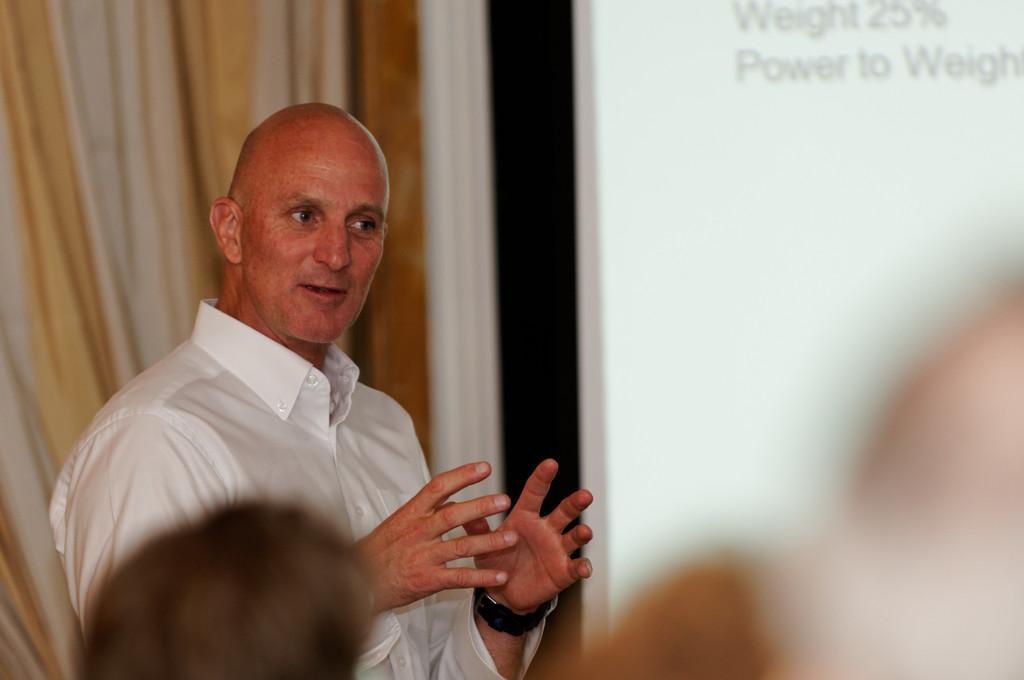Could you give a brief overview of what you see in this image? In the picture there is a person present, in front of a person there is people present, behind the person there is a curtain. 